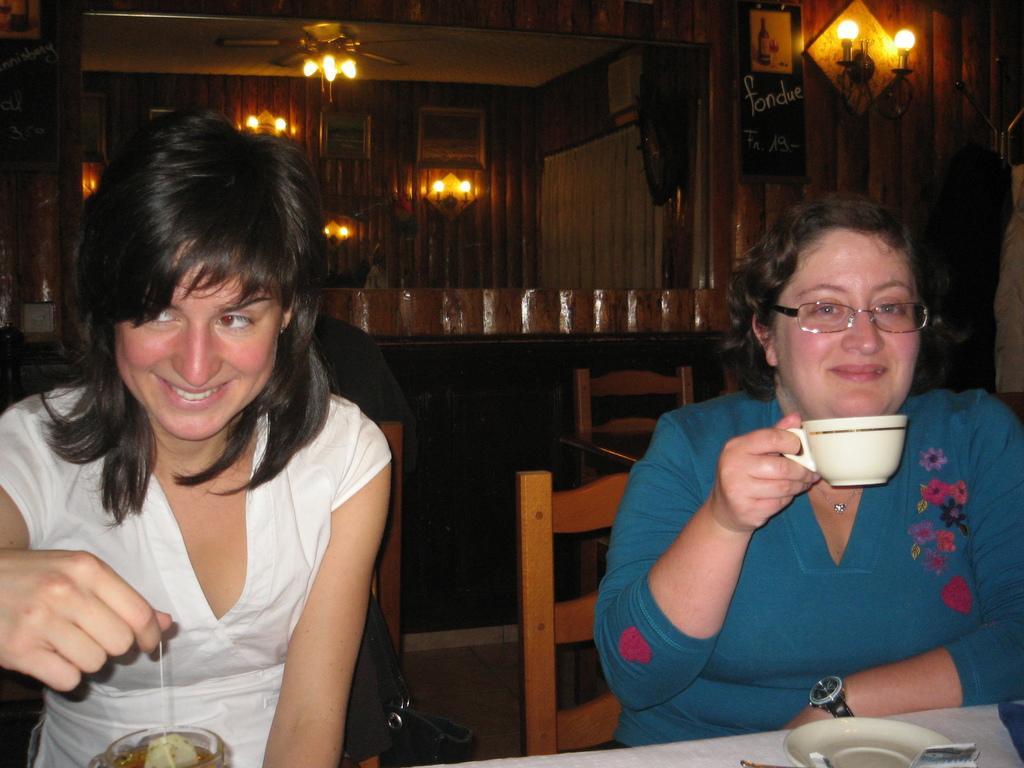Describe this image in one or two sentences. Here we can see a woman is sitting on the chair and she is smiling, and in front her is the table and tea cup on it and some other objects on it, and at beside a woman is sitting and drinking some liquid and her are the lights. 